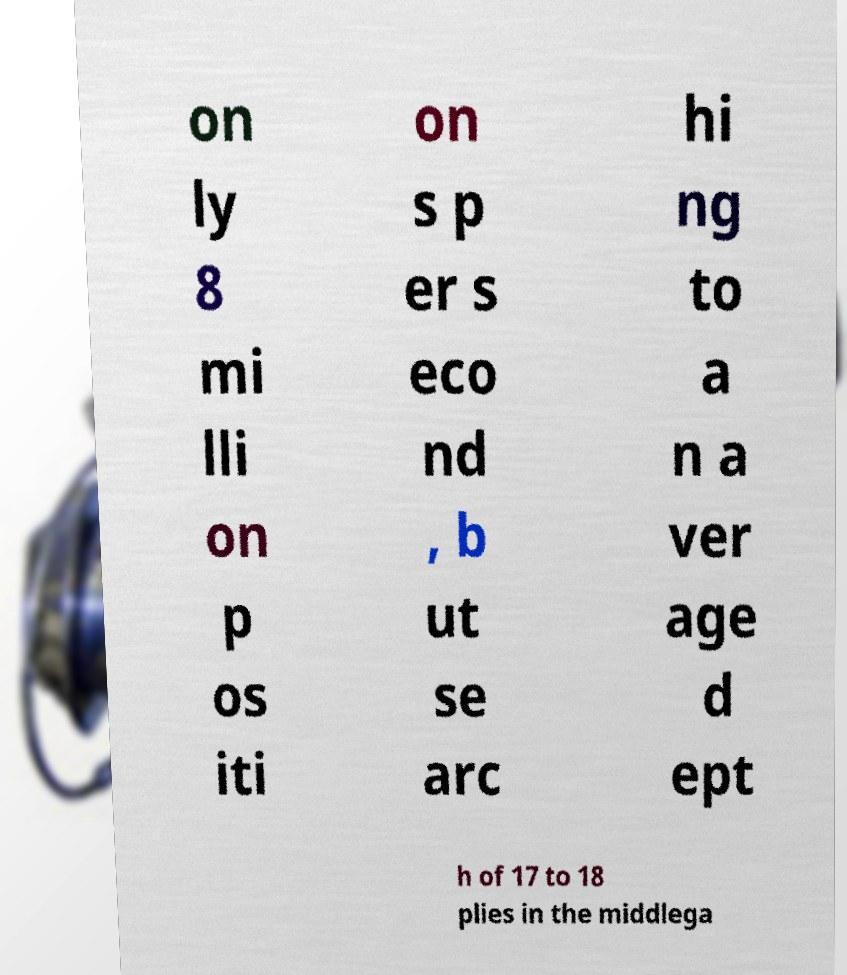There's text embedded in this image that I need extracted. Can you transcribe it verbatim? on ly 8 mi lli on p os iti on s p er s eco nd , b ut se arc hi ng to a n a ver age d ept h of 17 to 18 plies in the middlega 